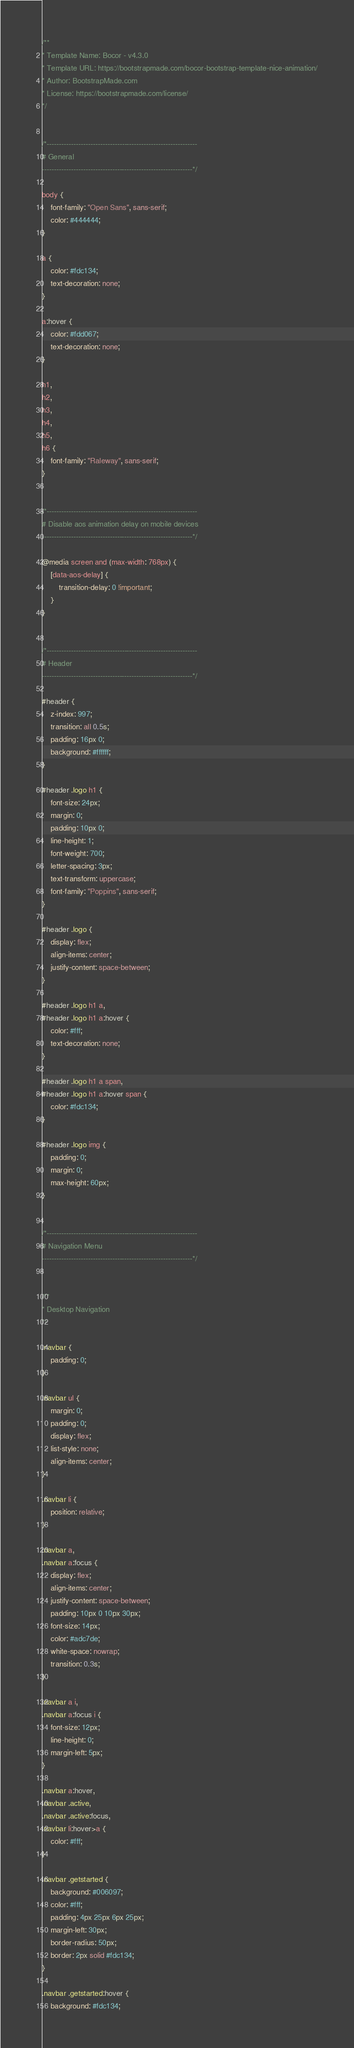Convert code to text. <code><loc_0><loc_0><loc_500><loc_500><_CSS_>/**
* Template Name: Bocor - v4.3.0
* Template URL: https://bootstrapmade.com/bocor-bootstrap-template-nice-animation/
* Author: BootstrapMade.com
* License: https://bootstrapmade.com/license/
*/


/*--------------------------------------------------------------
# General
--------------------------------------------------------------*/

body {
    font-family: "Open Sans", sans-serif;
    color: #444444;
}

a {
    color: #fdc134;
    text-decoration: none;
}

a:hover {
    color: #fdd067;
    text-decoration: none;
}

h1,
h2,
h3,
h4,
h5,
h6 {
    font-family: "Raleway", sans-serif;
}


/*--------------------------------------------------------------
# Disable aos animation delay on mobile devices
--------------------------------------------------------------*/

@media screen and (max-width: 768px) {
    [data-aos-delay] {
        transition-delay: 0 !important;
    }
}


/*--------------------------------------------------------------
# Header
--------------------------------------------------------------*/

#header {
    z-index: 997;
    transition: all 0.5s;
    padding: 16px 0;
    background: #ffffff;
}

#header .logo h1 {
    font-size: 24px;
    margin: 0;
    padding: 10px 0;
    line-height: 1;
    font-weight: 700;
    letter-spacing: 3px;
    text-transform: uppercase;
    font-family: "Poppins", sans-serif;
}

#header .logo {
    display: flex;
    align-items: center;
    justify-content: space-between;
}

#header .logo h1 a,
#header .logo h1 a:hover {
    color: #fff;
    text-decoration: none;
}

#header .logo h1 a span,
#header .logo h1 a:hover span {
    color: #fdc134;
}

#header .logo img {
    padding: 0;
    margin: 0;
    max-height: 60px;
}


/*--------------------------------------------------------------
# Navigation Menu
--------------------------------------------------------------*/


/**
* Desktop Navigation 
*/

.navbar {
    padding: 0;
}

.navbar ul {
    margin: 0;
    padding: 0;
    display: flex;
    list-style: none;
    align-items: center;
}

.navbar li {
    position: relative;
}

.navbar a,
.navbar a:focus {
    display: flex;
    align-items: center;
    justify-content: space-between;
    padding: 10px 0 10px 30px;
    font-size: 14px;
    color: #adc7de;
    white-space: nowrap;
    transition: 0.3s;
}

.navbar a i,
.navbar a:focus i {
    font-size: 12px;
    line-height: 0;
    margin-left: 5px;
}

.navbar a:hover,
.navbar .active,
.navbar .active:focus,
.navbar li:hover>a {
    color: #fff;
}

.navbar .getstarted {
    background: #006097;
    color: #fff;
    padding: 4px 25px 6px 25px;
    margin-left: 30px;
    border-radius: 50px;
    border: 2px solid #fdc134;
}

.navbar .getstarted:hover {
    background: #fdc134;</code> 